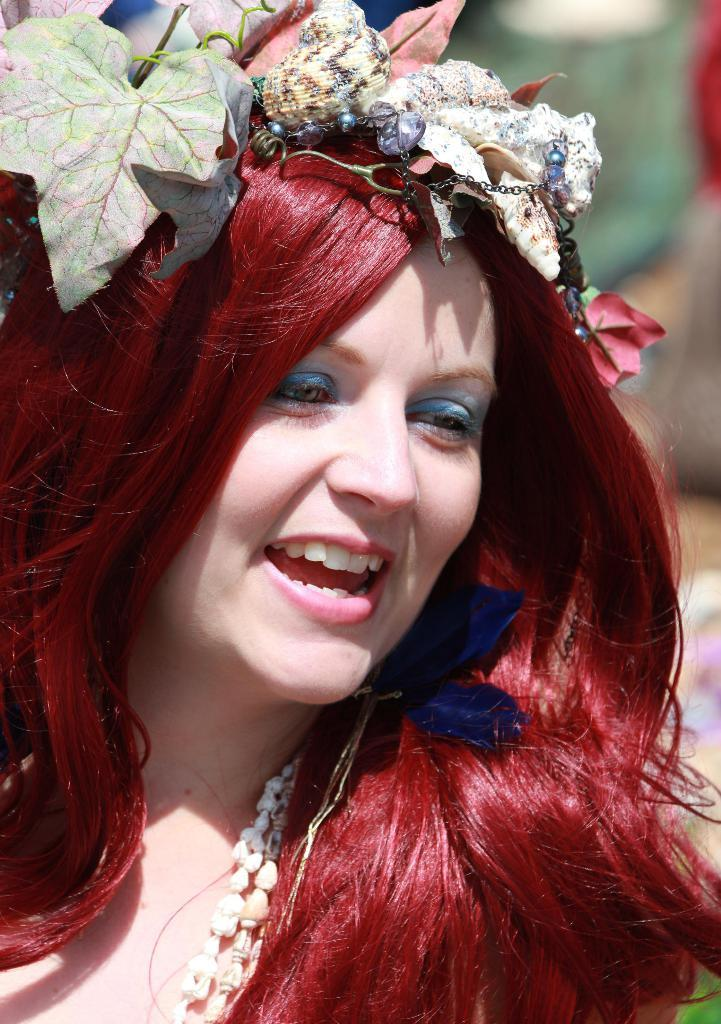Who is the main subject in the image? There is a woman in the image. What is unique about the woman's appearance? The woman has leaves and other objects on her head. What is the woman's facial expression? The woman is smiling. Can you describe the background of the image? There is a blurred image in the background of the picture. How many boots can be seen on the woman's feet in the image? There are no boots visible in the image; the woman has leaves and other objects on her head, but her feet are not shown. 